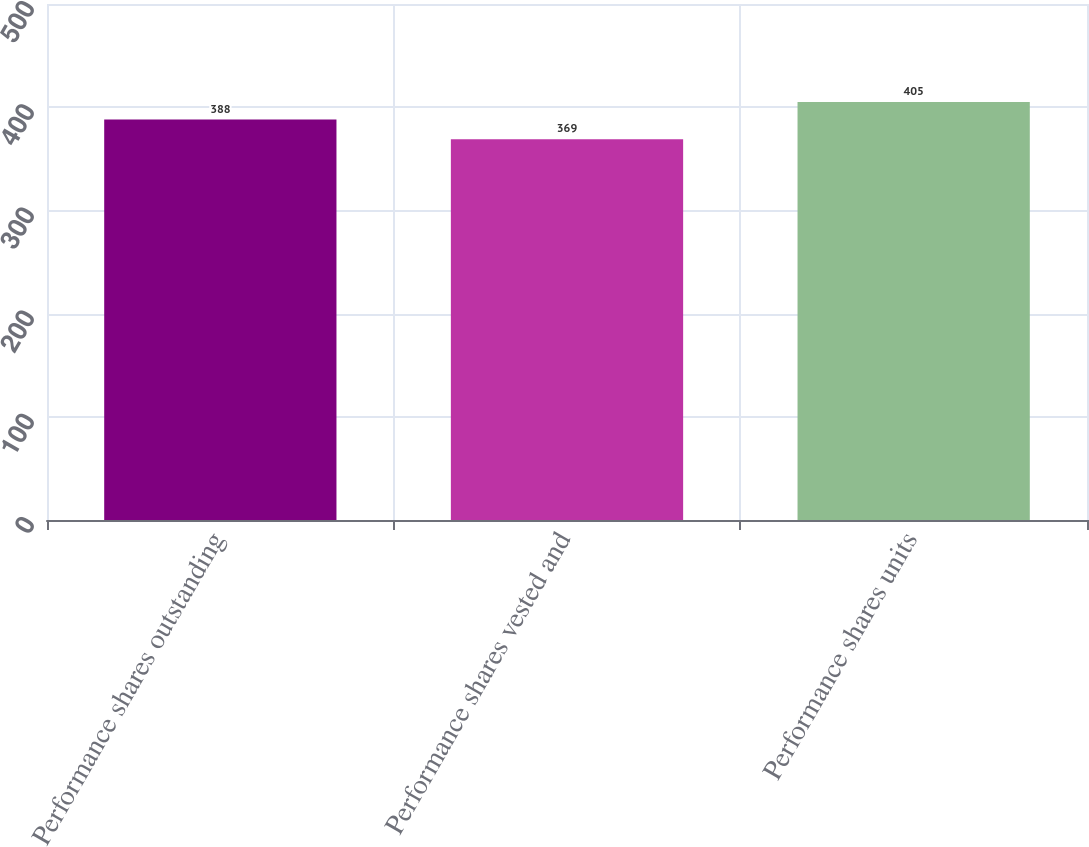<chart> <loc_0><loc_0><loc_500><loc_500><bar_chart><fcel>Performance shares outstanding<fcel>Performance shares vested and<fcel>Performance shares units<nl><fcel>388<fcel>369<fcel>405<nl></chart> 